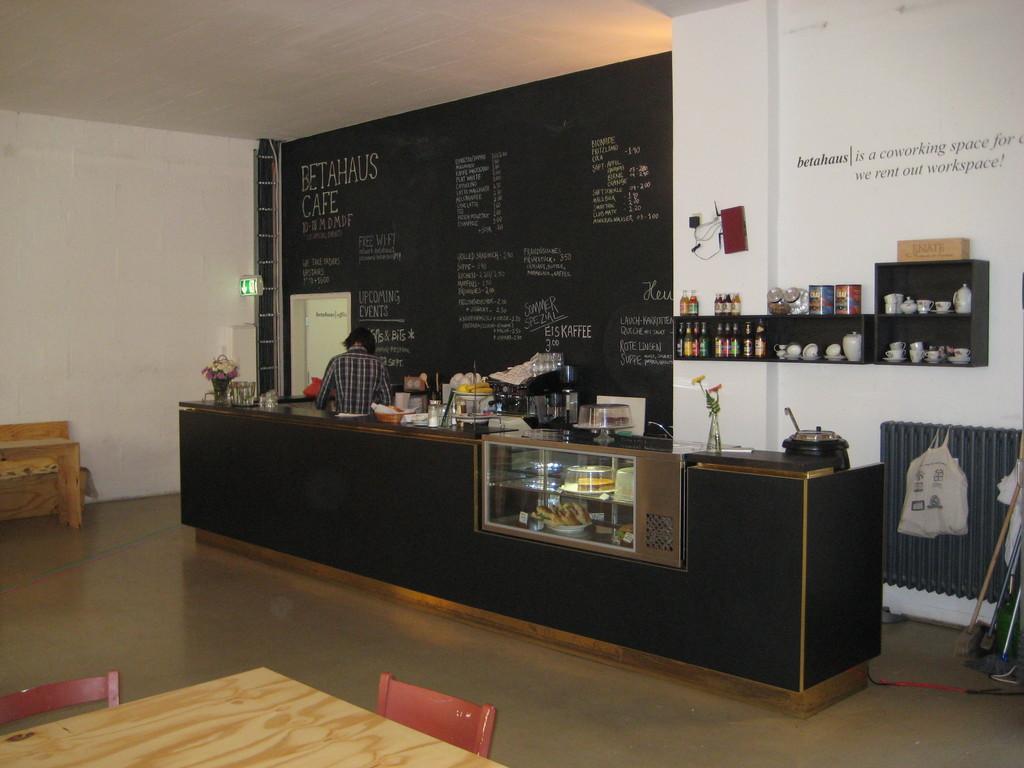In one or two sentences, can you explain what this image depicts? In this picture I can see a table which has some objects on it. On the right side I can see wooden shelf which has some objects on it. This shelf is attached to the wall. Here I can see a table and chairs. In the background I can see some wooden objects and black color wall which has something written on it. 